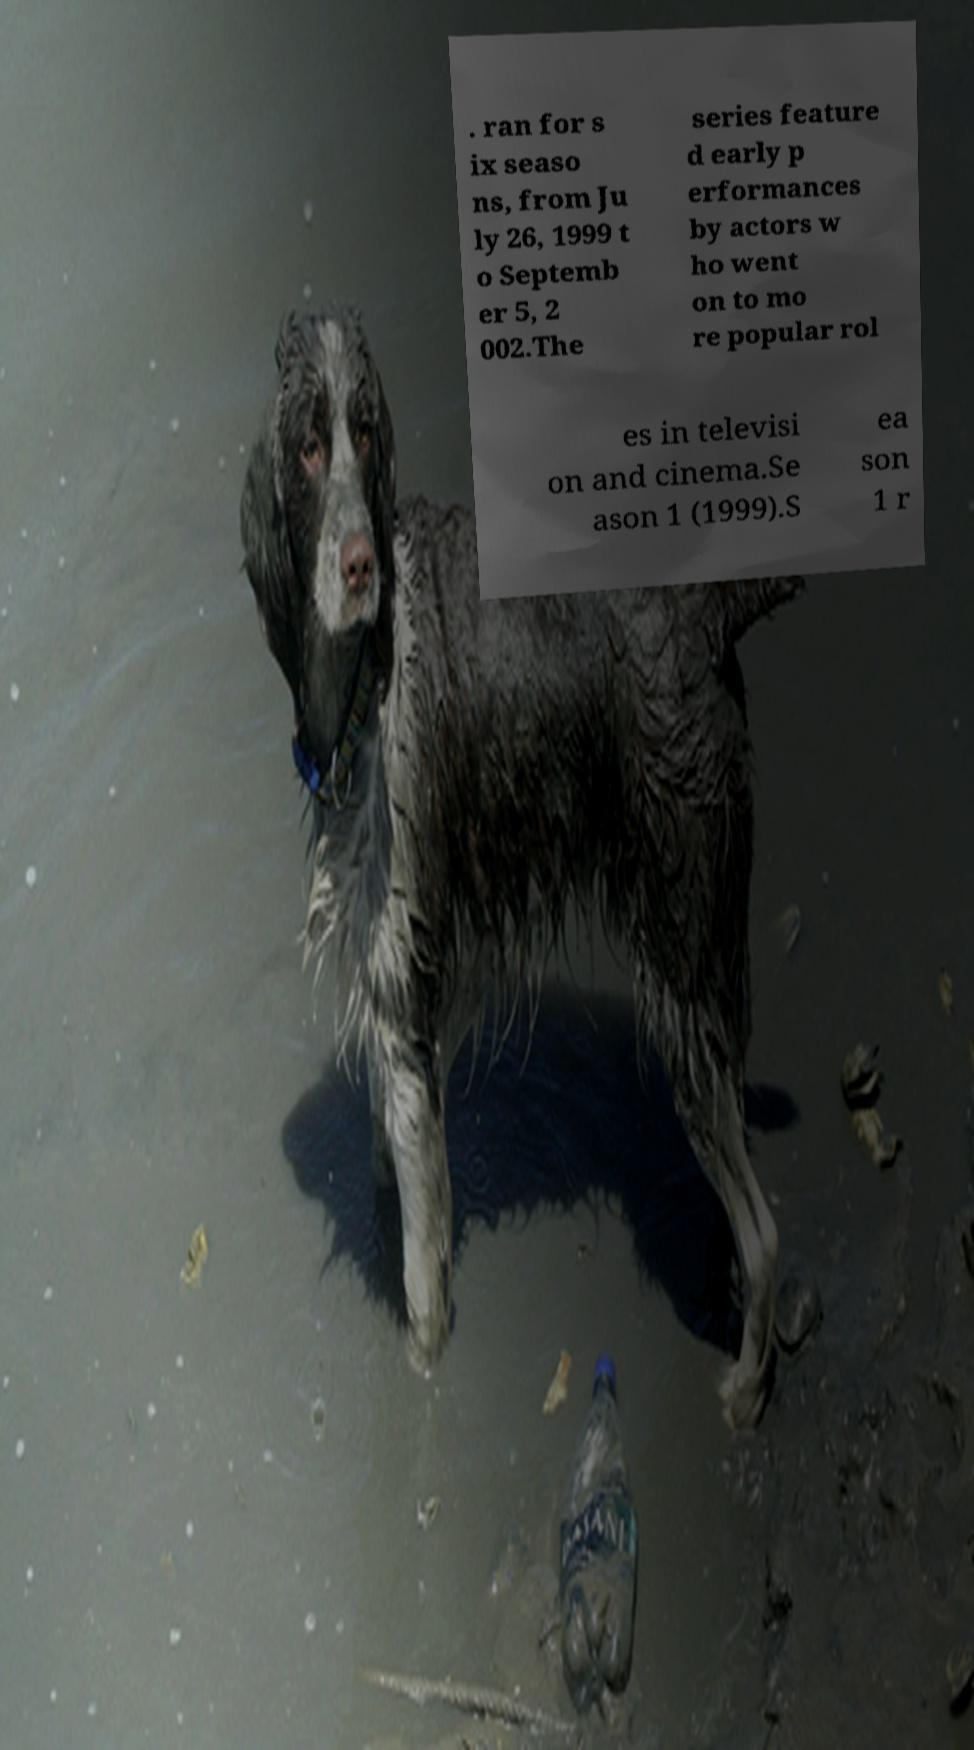Could you extract and type out the text from this image? . ran for s ix seaso ns, from Ju ly 26, 1999 t o Septemb er 5, 2 002.The series feature d early p erformances by actors w ho went on to mo re popular rol es in televisi on and cinema.Se ason 1 (1999).S ea son 1 r 